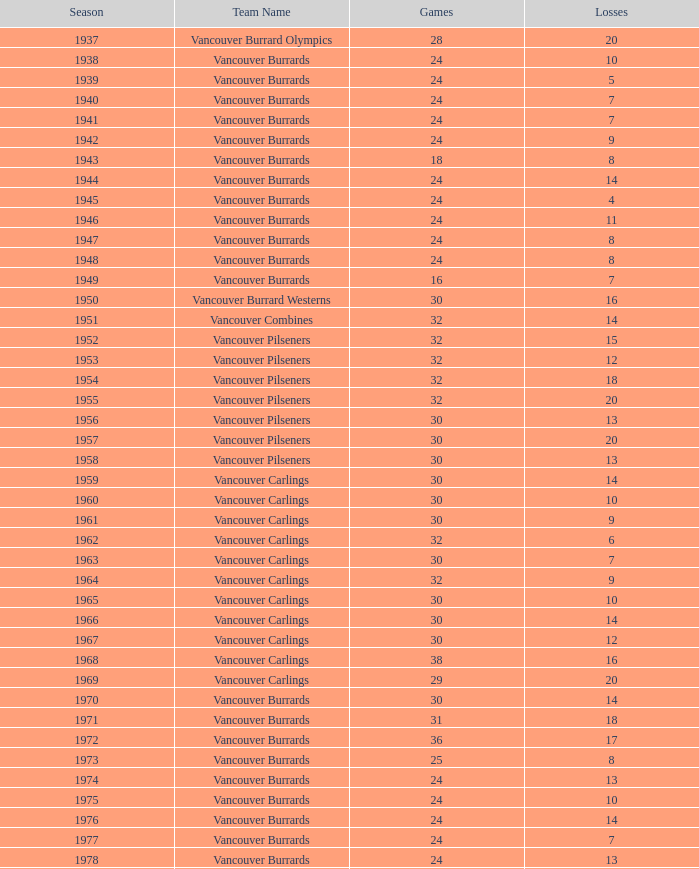What is the overall point count for the vancouver burrards when they have less than 9 losses and over 24 games played? 1.0. 